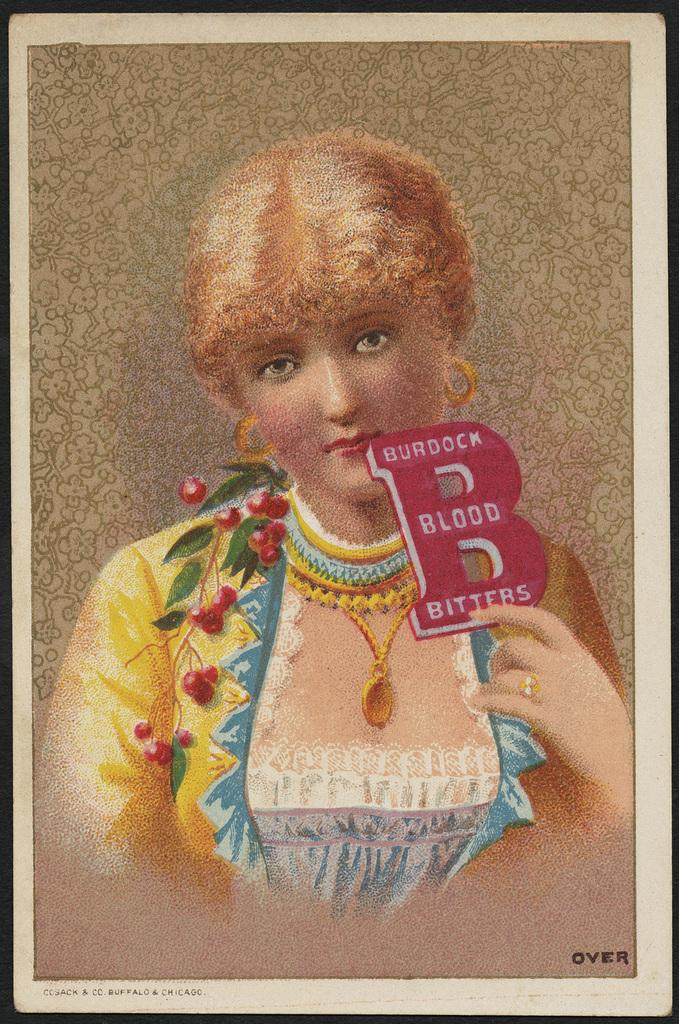What object is present in the image that typically holds a photo? There is a photo frame in the image. What can be seen inside the photo frame? The photo frame contains a person's photo. Is there any additional information on the photo frame besides the photo? Yes, there is text written on the photo frame. How many toes are visible on the person's photo in the image? There are no toes visible on the person's photo in the image, as it is a photo of a person's face or upper body. 